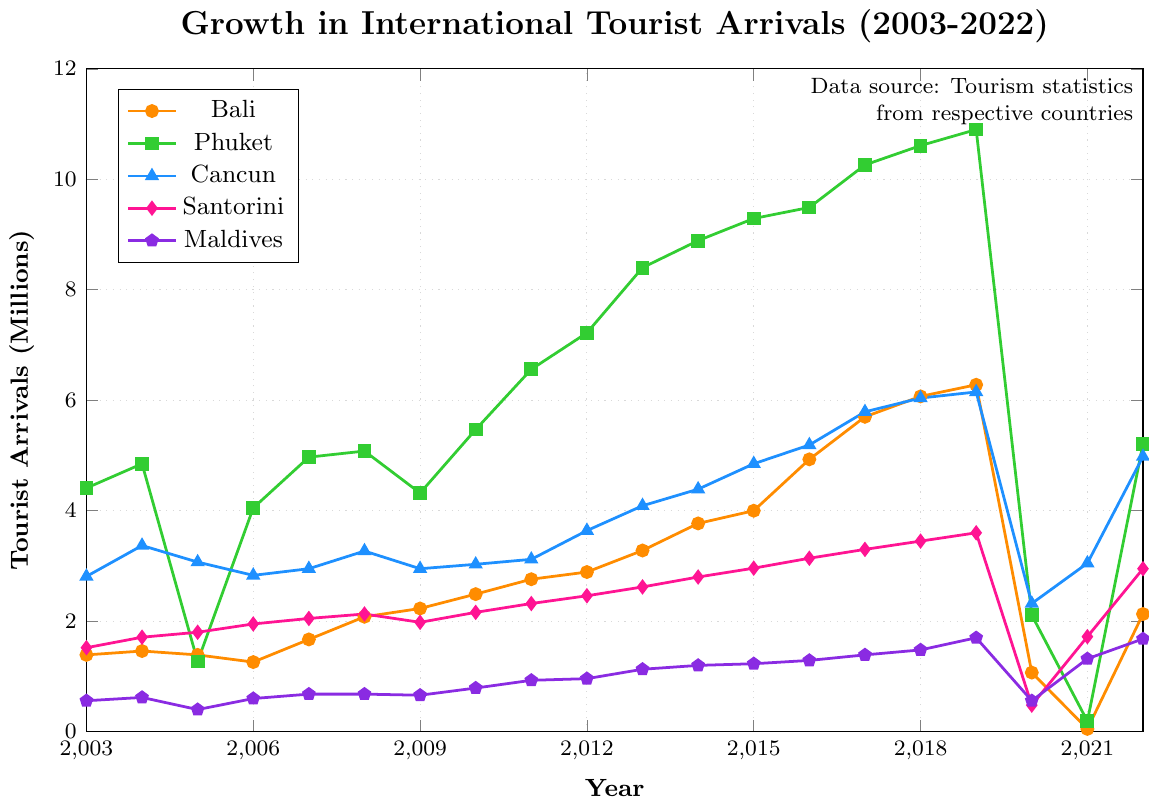Which vacation spot saw the highest peak in tourist arrivals over the last 20 years? The figure shows that Phuket had the highest tourist arrivals, peaking at about 10.90 million in 2019.
Answer: Phuket Which vacation spots had the lowest tourist arrivals in 2021? By examining the values for 2021, Bali had the lowest tourist arrivals with only 0.05 million.
Answer: Bali In which year did Bali experience a sudden drop in tourist arrivals, and what were the tourist arrivals that year? Bali experienced a sudden drop in 2020, going from 6.28 million in 2019 to 1.07 million in 2020.
Answer: 2020, 1.07 million What was the difference in tourist arrivals between Cancun and Santorini in 2022? In 2022, Cancun had 4.98 million arrivals and Santorini had 2.95 million. The difference is 4.98 - 2.95 = 2.03 million.
Answer: 2.03 million How did the international tourist arrivals in the Maldives in 2005 compare to those in 2015? The Maldives had 0.40 million tourist arrivals in 2005 and 1.23 million in 2015. This is an increase of 1.23 - 0.40 = 0.83 million.
Answer: 0.83 million Which destination had the most stable growth in tourist arrivals from 2003 to 2019? By examining the trends, the Maldives had the most stable growth, with a relatively smooth and gradual increase in tourist arrivals.
Answer: Maldives How did the COVID-19 pandemic impact tourist arrivals in Bali and Phuket in 2020? In 2020, tourist arrivals in Bali dropped sharply from 6.28 million in 2019 to 1.07 million. Similarly, in Phuket, arrivals fell from 10.90 million in 2019 to 2.11 million.
Answer: Drastic drop Which two vacation spots had tourist arrivals fall below 1 million after peaking before 2021? Bali and Phuket had arrivals fall below 1 million. Bali fell to 0.05 million in 2021 after peaking at 6.28 million, and Phuket fell to 0.19 million in 2021 after peaking at 10.90 million.
Answer: Bali and Phuket Considering tourist arrivals in 2017, which destination was more popular: Cancun or Santorini? In 2017, Cancun had 5.79 million tourist arrivals, while Santorini had 3.30 million. Thus, Cancun was more popular.
Answer: Cancun What was the combined total of tourist arrivals for all the vacation spots in 2022? Summing the values for 2022: Bali (2.13) + Phuket (5.21) + Cancun (4.98) + Santorini (2.95) + Maldives (1.68) = 16.95 million.
Answer: 16.95 million 